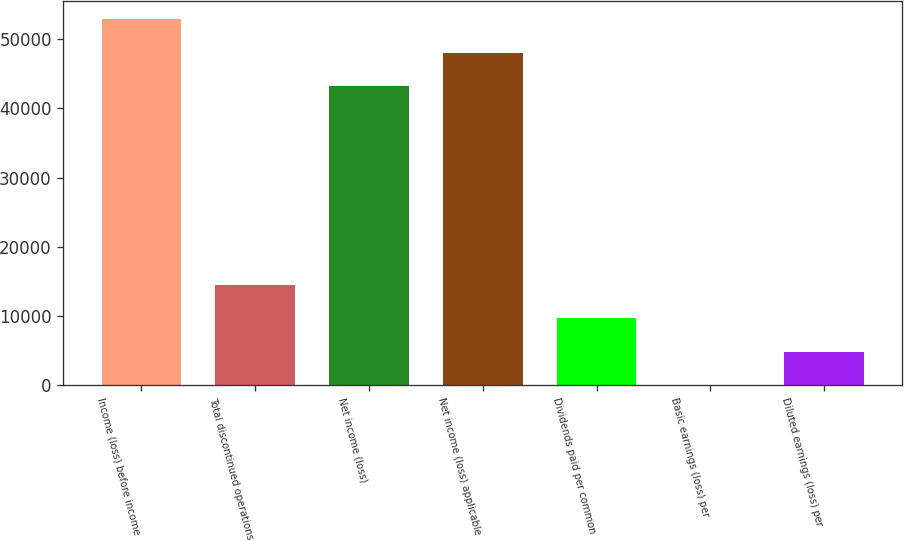Convert chart to OTSL. <chart><loc_0><loc_0><loc_500><loc_500><bar_chart><fcel>Income (loss) before income<fcel>Total discontinued operations<fcel>Net income (loss)<fcel>Net income (loss) applicable<fcel>Dividends paid per common<fcel>Basic earnings (loss) per<fcel>Diluted earnings (loss) per<nl><fcel>52883.4<fcel>14495.2<fcel>43220<fcel>48051.7<fcel>9663.54<fcel>0.18<fcel>4831.86<nl></chart> 